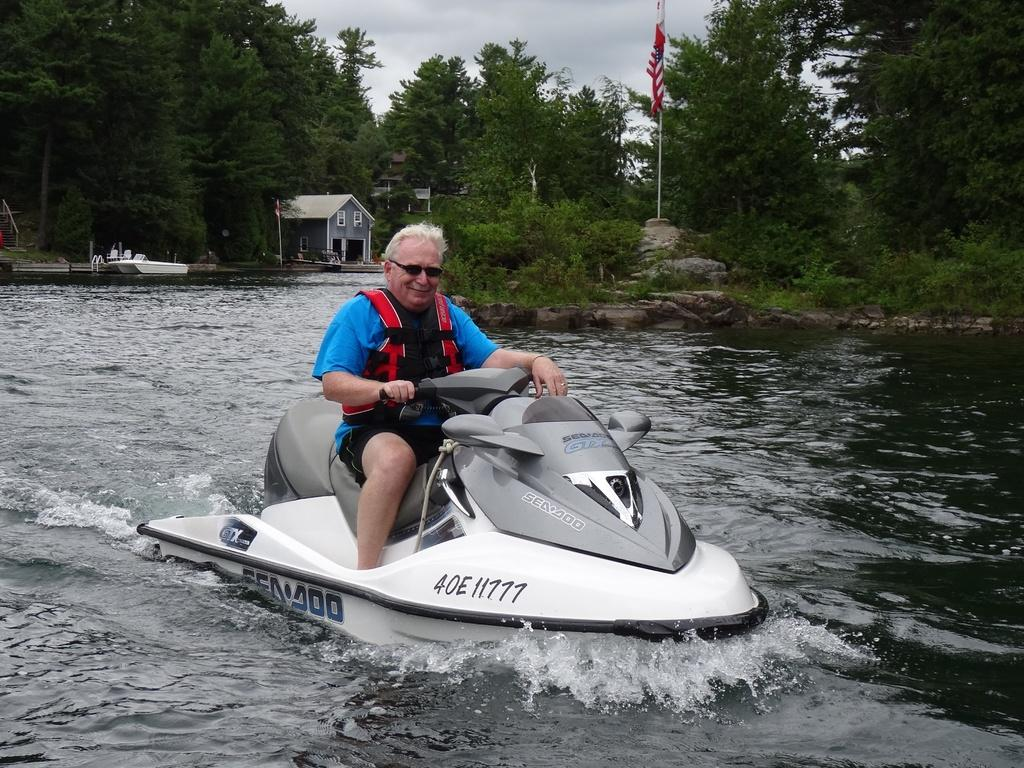<image>
Give a short and clear explanation of the subsequent image. An older man in a blue shirt rides a SeaDoo jet ski in a lake. 